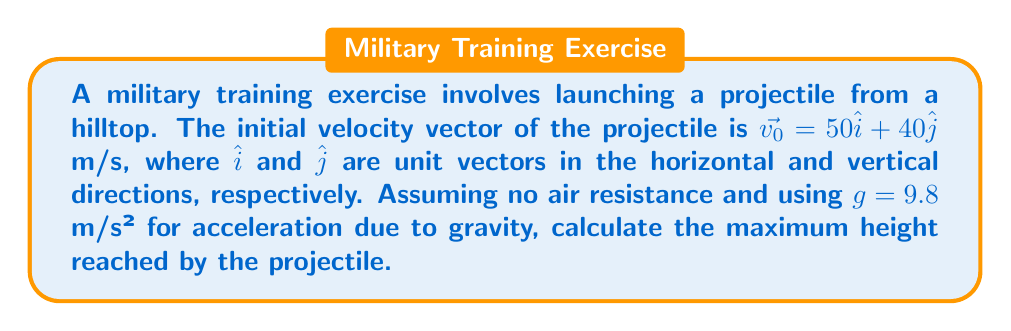Help me with this question. To find the maximum height, we'll use vector operations and kinematics:

1) The vertical component of velocity $v_y$ determines the maximum height. Initially, $v_y = 40$ m/s.

2) At maximum height, the vertical velocity becomes zero. We can use the equation:
   $$v_y^2 = v_{0y}^2 + 2a_y\Delta y$$

3) Substituting known values:
   $$0^2 = 40^2 + 2(-9.8)\Delta y$$

4) Solving for $\Delta y$:
   $$0 = 1600 - 19.6\Delta y$$
   $$19.6\Delta y = 1600$$
   $$\Delta y = \frac{1600}{19.6} = 81.63$$

5) Therefore, the maximum height reached is 81.63 meters above the launch point.
Answer: 81.63 m 